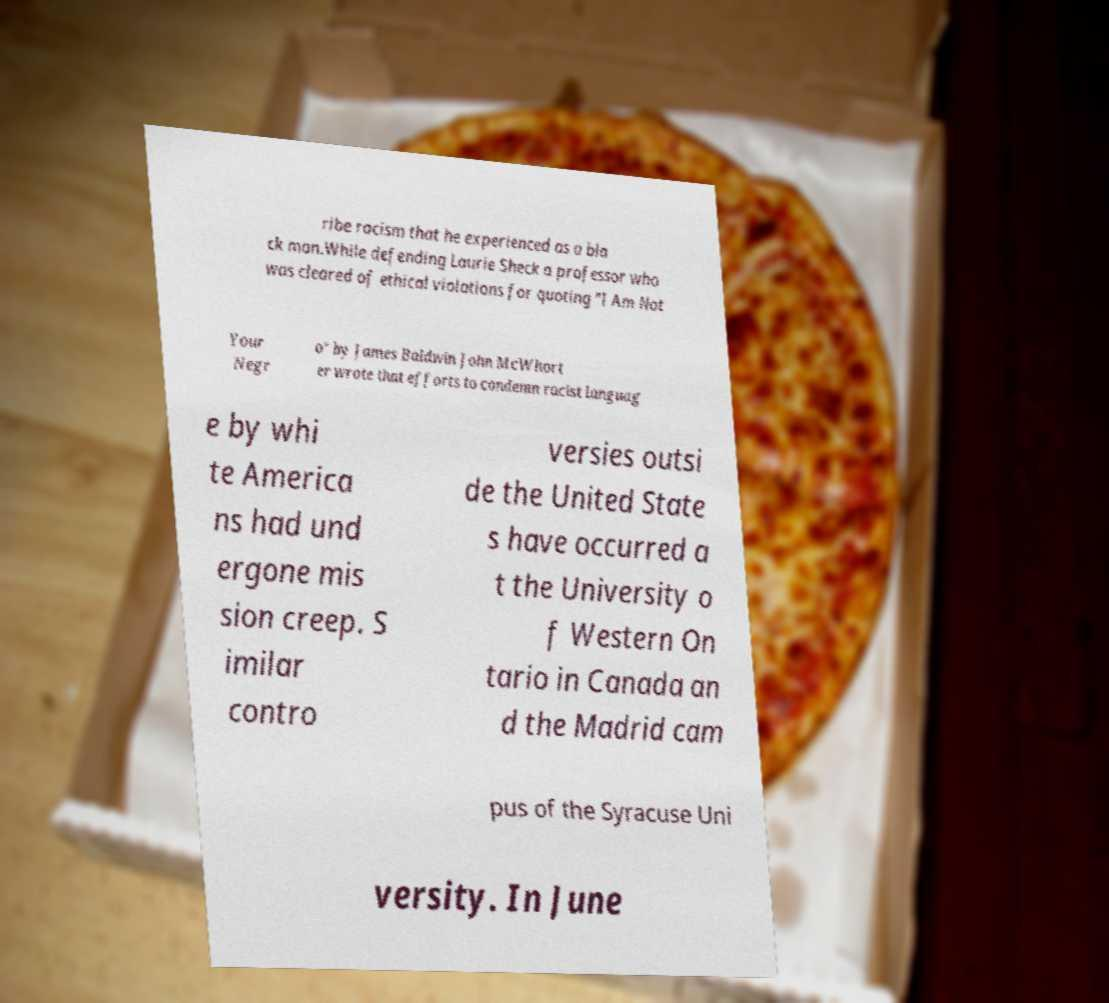For documentation purposes, I need the text within this image transcribed. Could you provide that? ribe racism that he experienced as a bla ck man.While defending Laurie Sheck a professor who was cleared of ethical violations for quoting "I Am Not Your Negr o" by James Baldwin John McWhort er wrote that efforts to condemn racist languag e by whi te America ns had und ergone mis sion creep. S imilar contro versies outsi de the United State s have occurred a t the University o f Western On tario in Canada an d the Madrid cam pus of the Syracuse Uni versity. In June 